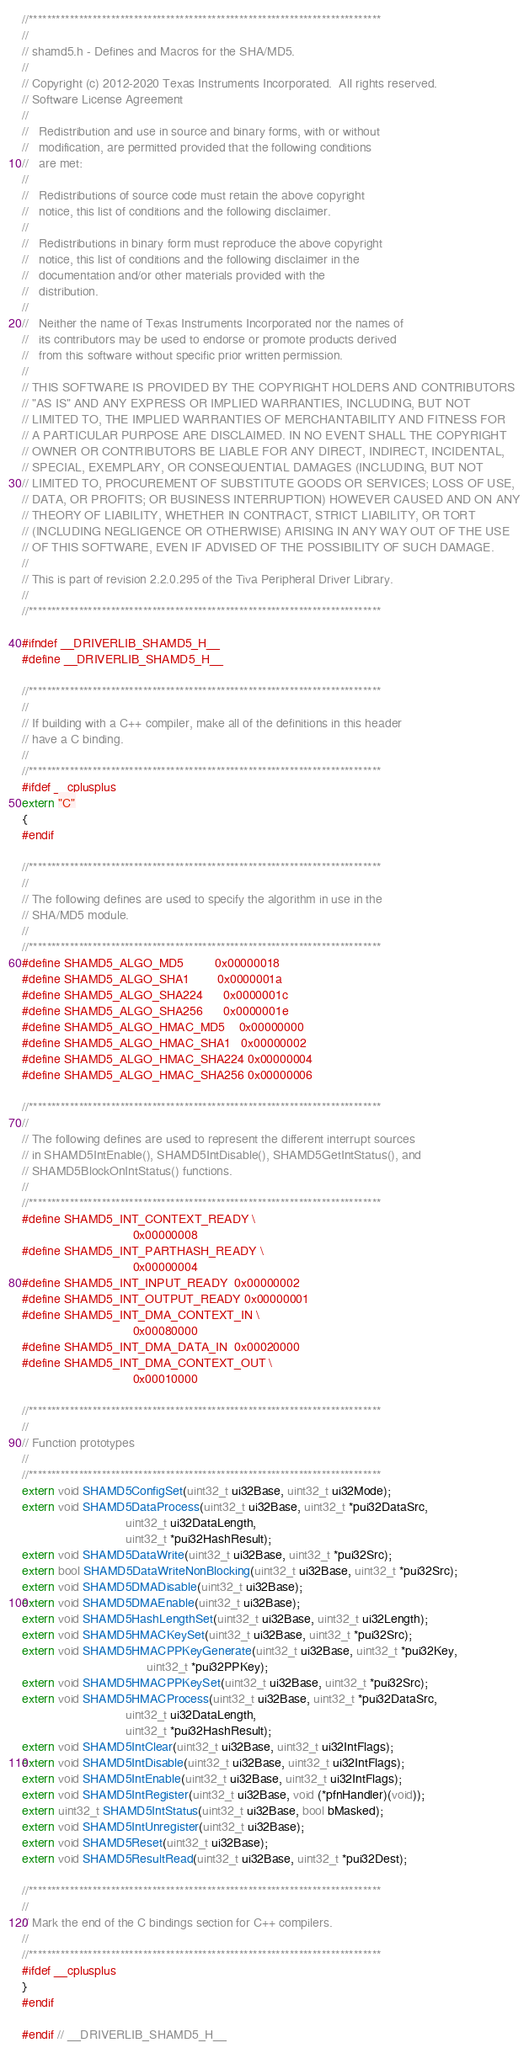<code> <loc_0><loc_0><loc_500><loc_500><_C_>//*****************************************************************************
//
// shamd5.h - Defines and Macros for the SHA/MD5.
//
// Copyright (c) 2012-2020 Texas Instruments Incorporated.  All rights reserved.
// Software License Agreement
// 
//   Redistribution and use in source and binary forms, with or without
//   modification, are permitted provided that the following conditions
//   are met:
// 
//   Redistributions of source code must retain the above copyright
//   notice, this list of conditions and the following disclaimer.
// 
//   Redistributions in binary form must reproduce the above copyright
//   notice, this list of conditions and the following disclaimer in the
//   documentation and/or other materials provided with the  
//   distribution.
// 
//   Neither the name of Texas Instruments Incorporated nor the names of
//   its contributors may be used to endorse or promote products derived
//   from this software without specific prior written permission.
// 
// THIS SOFTWARE IS PROVIDED BY THE COPYRIGHT HOLDERS AND CONTRIBUTORS
// "AS IS" AND ANY EXPRESS OR IMPLIED WARRANTIES, INCLUDING, BUT NOT
// LIMITED TO, THE IMPLIED WARRANTIES OF MERCHANTABILITY AND FITNESS FOR
// A PARTICULAR PURPOSE ARE DISCLAIMED. IN NO EVENT SHALL THE COPYRIGHT
// OWNER OR CONTRIBUTORS BE LIABLE FOR ANY DIRECT, INDIRECT, INCIDENTAL,
// SPECIAL, EXEMPLARY, OR CONSEQUENTIAL DAMAGES (INCLUDING, BUT NOT
// LIMITED TO, PROCUREMENT OF SUBSTITUTE GOODS OR SERVICES; LOSS OF USE,
// DATA, OR PROFITS; OR BUSINESS INTERRUPTION) HOWEVER CAUSED AND ON ANY
// THEORY OF LIABILITY, WHETHER IN CONTRACT, STRICT LIABILITY, OR TORT
// (INCLUDING NEGLIGENCE OR OTHERWISE) ARISING IN ANY WAY OUT OF THE USE
// OF THIS SOFTWARE, EVEN IF ADVISED OF THE POSSIBILITY OF SUCH DAMAGE.
// 
// This is part of revision 2.2.0.295 of the Tiva Peripheral Driver Library.
//
//*****************************************************************************

#ifndef __DRIVERLIB_SHAMD5_H__
#define __DRIVERLIB_SHAMD5_H__

//*****************************************************************************
//
// If building with a C++ compiler, make all of the definitions in this header
// have a C binding.
//
//*****************************************************************************
#ifdef __cplusplus
extern "C"
{
#endif

//*****************************************************************************
//
// The following defines are used to specify the algorithm in use in the
// SHA/MD5 module.
//
//*****************************************************************************
#define SHAMD5_ALGO_MD5         0x00000018
#define SHAMD5_ALGO_SHA1        0x0000001a
#define SHAMD5_ALGO_SHA224      0x0000001c
#define SHAMD5_ALGO_SHA256      0x0000001e
#define SHAMD5_ALGO_HMAC_MD5    0x00000000
#define SHAMD5_ALGO_HMAC_SHA1   0x00000002
#define SHAMD5_ALGO_HMAC_SHA224 0x00000004
#define SHAMD5_ALGO_HMAC_SHA256 0x00000006

//*****************************************************************************
//
// The following defines are used to represent the different interrupt sources
// in SHAMD5IntEnable(), SHAMD5IntDisable(), SHAMD5GetIntStatus(), and
// SHAMD5BlockOnIntStatus() functions.
//
//*****************************************************************************
#define SHAMD5_INT_CONTEXT_READY \
                                0x00000008
#define SHAMD5_INT_PARTHASH_READY \
                                0x00000004
#define SHAMD5_INT_INPUT_READY  0x00000002
#define SHAMD5_INT_OUTPUT_READY 0x00000001
#define SHAMD5_INT_DMA_CONTEXT_IN \
                                0x00080000
#define SHAMD5_INT_DMA_DATA_IN  0x00020000
#define SHAMD5_INT_DMA_CONTEXT_OUT \
                                0x00010000

//*****************************************************************************
//
// Function prototypes
//
//*****************************************************************************
extern void SHAMD5ConfigSet(uint32_t ui32Base, uint32_t ui32Mode);
extern void SHAMD5DataProcess(uint32_t ui32Base, uint32_t *pui32DataSrc,
                              uint32_t ui32DataLength,
                              uint32_t *pui32HashResult);
extern void SHAMD5DataWrite(uint32_t ui32Base, uint32_t *pui32Src);
extern bool SHAMD5DataWriteNonBlocking(uint32_t ui32Base, uint32_t *pui32Src);
extern void SHAMD5DMADisable(uint32_t ui32Base);
extern void SHAMD5DMAEnable(uint32_t ui32Base);
extern void SHAMD5HashLengthSet(uint32_t ui32Base, uint32_t ui32Length);
extern void SHAMD5HMACKeySet(uint32_t ui32Base, uint32_t *pui32Src);
extern void SHAMD5HMACPPKeyGenerate(uint32_t ui32Base, uint32_t *pui32Key,
                                    uint32_t *pui32PPKey);
extern void SHAMD5HMACPPKeySet(uint32_t ui32Base, uint32_t *pui32Src);
extern void SHAMD5HMACProcess(uint32_t ui32Base, uint32_t *pui32DataSrc,
                              uint32_t ui32DataLength,
                              uint32_t *pui32HashResult);
extern void SHAMD5IntClear(uint32_t ui32Base, uint32_t ui32IntFlags);
extern void SHAMD5IntDisable(uint32_t ui32Base, uint32_t ui32IntFlags);
extern void SHAMD5IntEnable(uint32_t ui32Base, uint32_t ui32IntFlags);
extern void SHAMD5IntRegister(uint32_t ui32Base, void (*pfnHandler)(void));
extern uint32_t SHAMD5IntStatus(uint32_t ui32Base, bool bMasked);
extern void SHAMD5IntUnregister(uint32_t ui32Base);
extern void SHAMD5Reset(uint32_t ui32Base);
extern void SHAMD5ResultRead(uint32_t ui32Base, uint32_t *pui32Dest);

//*****************************************************************************
//
// Mark the end of the C bindings section for C++ compilers.
//
//*****************************************************************************
#ifdef __cplusplus
}
#endif

#endif // __DRIVERLIB_SHAMD5_H__
</code> 